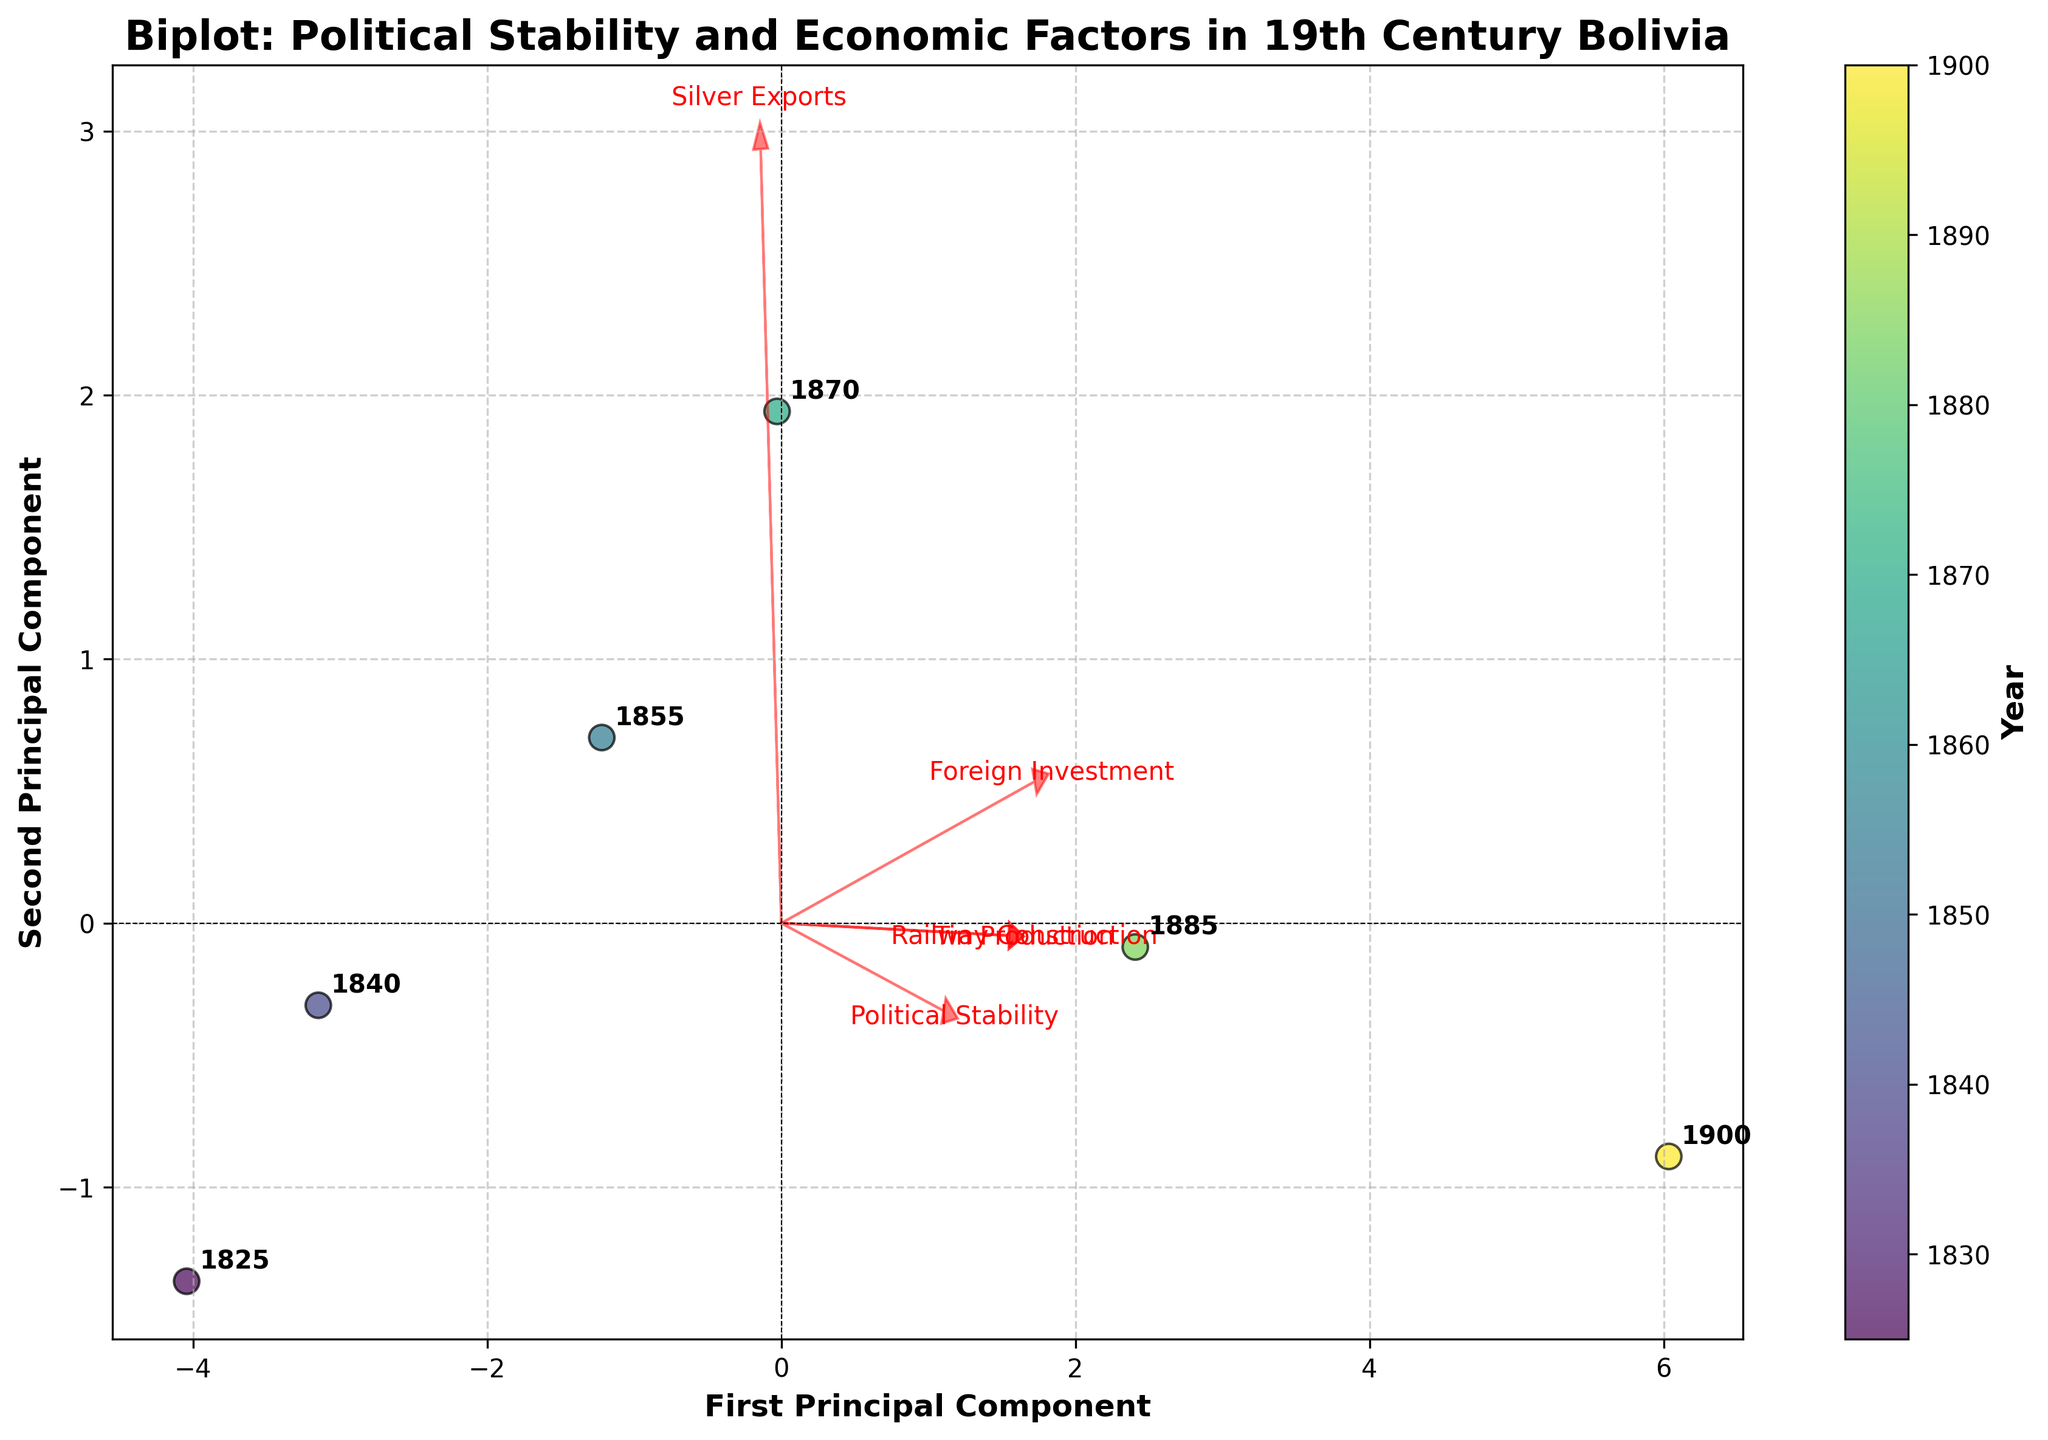What is the title of the biplot? The title of the plot is displayed at the top as "Biplot: Political Stability and Economic Factors in 19th Century Bolivia".
Answer: Biplot: Political Stability and Economic Factors in 19th Century Bolivia How many data points are shown in the biplot? Each data point corresponds to the years on the biplot. By counting the annotations, we find there are six data points.
Answer: 6 Which year corresponds to the highest value for the first principal component? The position of each year along the x-axis (first principal component) reveals the year with the highest value. The year 1900 appears farthest to the right.
Answer: 1900 What economic factor has the longest arrow pointing away from the origin? The length of the arrow indicates the magnitude of the component along the principal components. The arrow labeled "Foreign Investment" is the longest.
Answer: Foreign Investment Which economic factor is most positively correlated with Political Stability? The arrows' directions indicate the correlation. The arrow for "Foreign Investment" points in the same direction as "Political Stability".
Answer: Foreign Investment What can you infer about the relationship between Tin Production and Railway Construction? The arrows for these factors point in similar directions, indicating a positive correlation.
Answer: Positive correlation Between which two years did political stability increase the most significantly? Comparing the relative positions along the first principal component axis, political stability increased substantially from 1840 to 1855.
Answer: 1840 to 1855 Rank the years in terms of their value on the second principal component. Evaluating their position along the y-axis (second principal component), from highest to lowest: 1900, 1885, 1855, 1870, 1840, 1825.
Answer: 1900, 1885, 1855, 1870, 1840, 1825 How is Silver Exports related to the other economic factors? By examining the vectors, Silver Exports appears to have a moderate to a weak positive correlation with other economic factors, except Political Stability where the angle is slightly deviated.
Answer: Moderate to weak positive correlation 